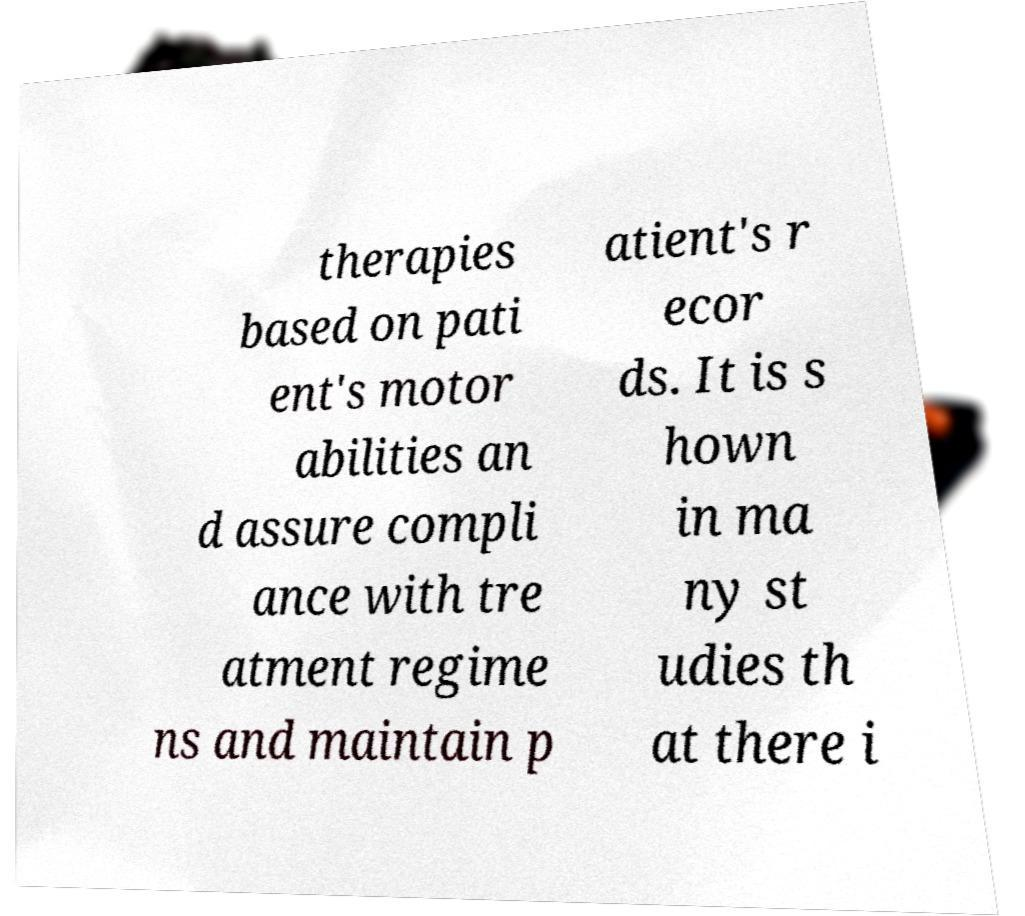Could you extract and type out the text from this image? therapies based on pati ent's motor abilities an d assure compli ance with tre atment regime ns and maintain p atient's r ecor ds. It is s hown in ma ny st udies th at there i 